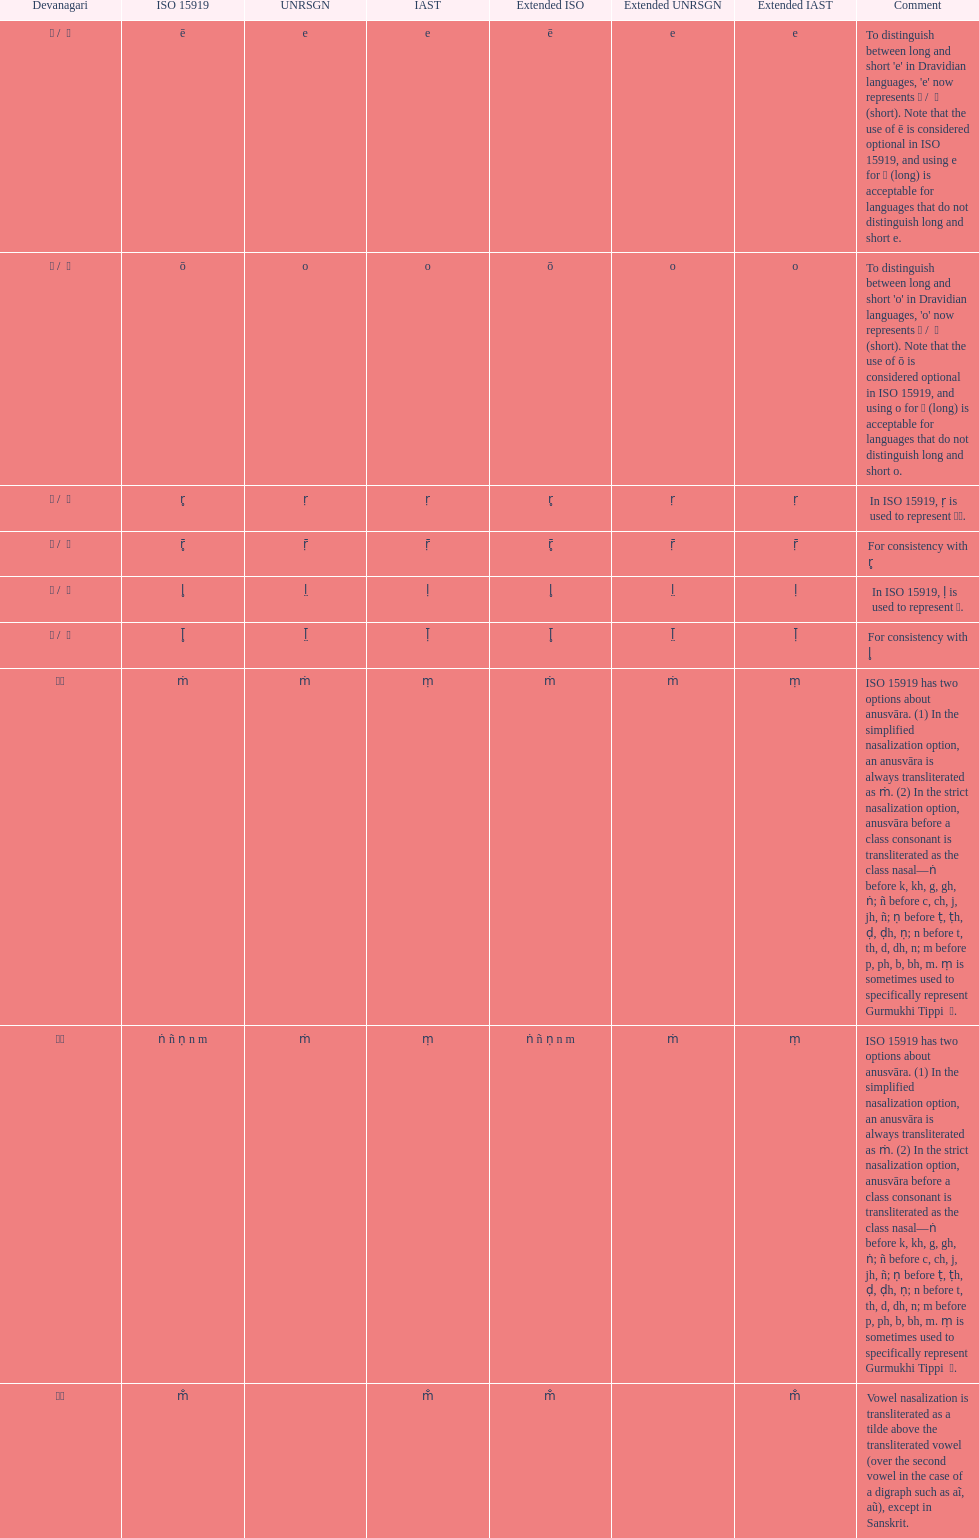What is listed previous to in iso 15919, &#7735; is used to represent &#2355;. under comments? For consistency with r̥. 